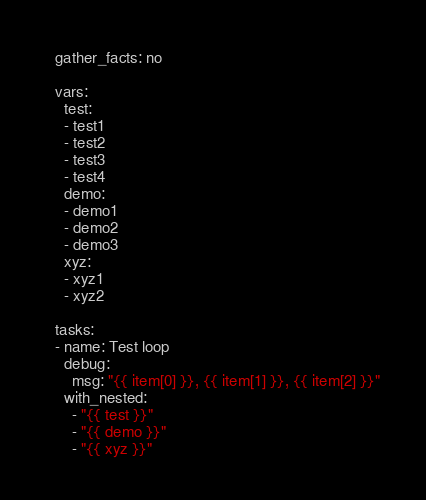<code> <loc_0><loc_0><loc_500><loc_500><_YAML_>  gather_facts: no

  vars:
    test:
    - test1
    - test2
    - test3
    - test4
    demo:
    - demo1
    - demo2
    - demo3
    xyz:
    - xyz1
    - xyz2

  tasks:
  - name: Test loop
    debug:
      msg: "{{ item[0] }}, {{ item[1] }}, {{ item[2] }}"
    with_nested:
      - "{{ test }}"
      - "{{ demo }}"
      - "{{ xyz }}"
</code> 